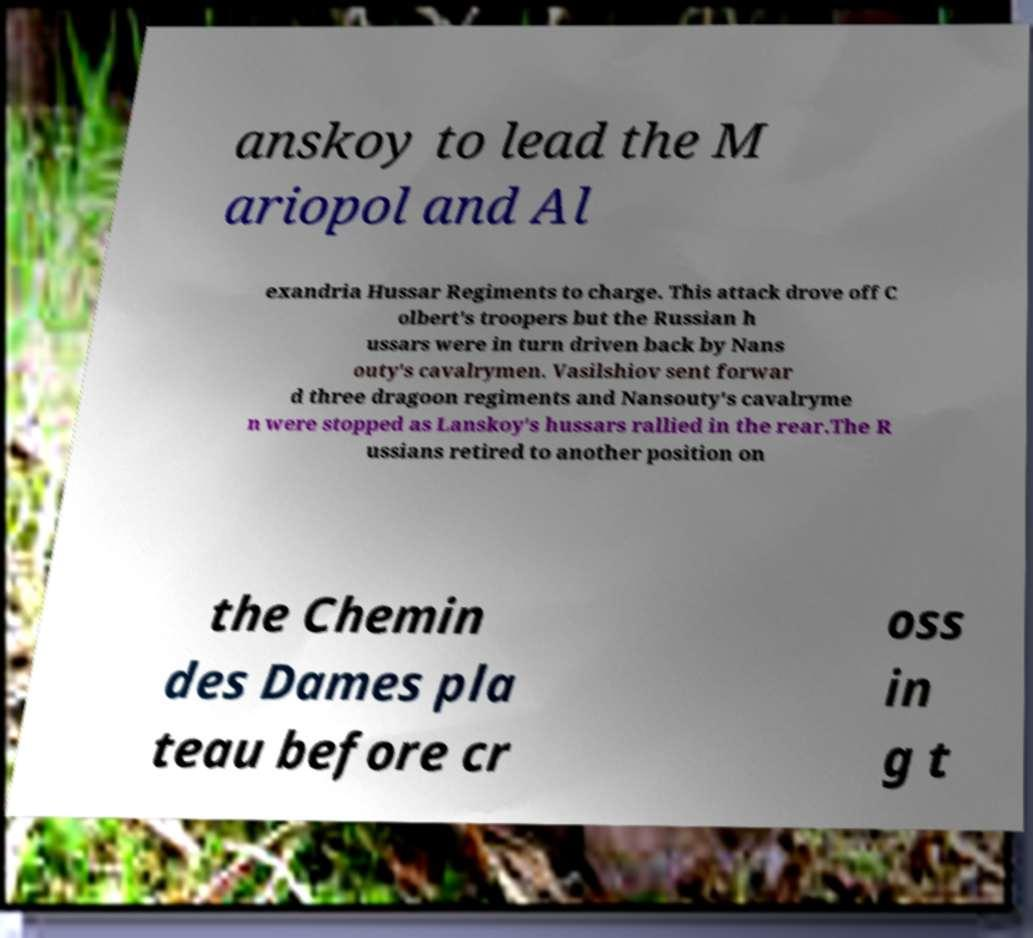Could you assist in decoding the text presented in this image and type it out clearly? anskoy to lead the M ariopol and Al exandria Hussar Regiments to charge. This attack drove off C olbert's troopers but the Russian h ussars were in turn driven back by Nans outy's cavalrymen. Vasilshiov sent forwar d three dragoon regiments and Nansouty's cavalryme n were stopped as Lanskoy's hussars rallied in the rear.The R ussians retired to another position on the Chemin des Dames pla teau before cr oss in g t 